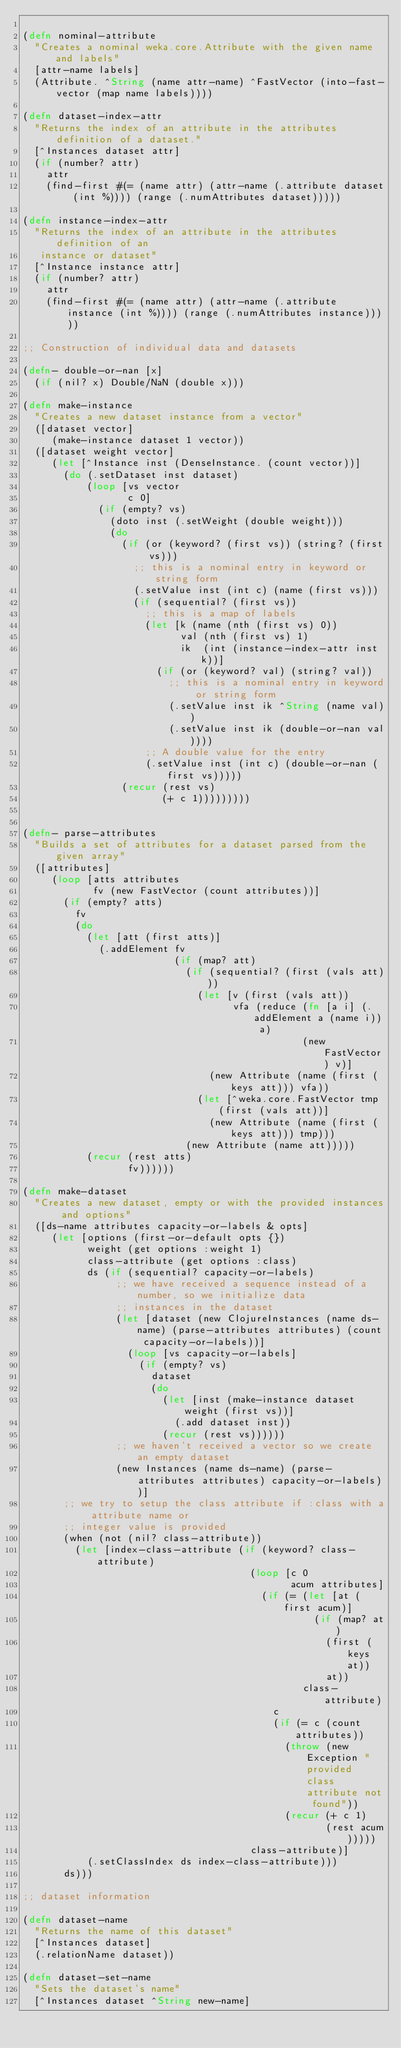<code> <loc_0><loc_0><loc_500><loc_500><_Clojure_>
(defn nominal-attribute
  "Creates a nominal weka.core.Attribute with the given name and labels"
  [attr-name labels]
  (Attribute. ^String (name attr-name) ^FastVector (into-fast-vector (map name labels))))

(defn dataset-index-attr
  "Returns the index of an attribute in the attributes definition of a dataset."
  [^Instances dataset attr]
  (if (number? attr)
    attr
    (find-first #(= (name attr) (attr-name (.attribute dataset (int %)))) (range (.numAttributes dataset)))))

(defn instance-index-attr
  "Returns the index of an attribute in the attributes definition of an
   instance or dataset"
  [^Instance instance attr]
  (if (number? attr)
    attr
    (find-first #(= (name attr) (attr-name (.attribute instance (int %)))) (range (.numAttributes instance)))))

;; Construction of individual data and datasets

(defn- double-or-nan [x]
  (if (nil? x) Double/NaN (double x)))

(defn make-instance
  "Creates a new dataset instance from a vector"
  ([dataset vector]
     (make-instance dataset 1 vector))
  ([dataset weight vector]
     (let [^Instance inst (DenseInstance. (count vector))]
       (do (.setDataset inst dataset)
           (loop [vs vector
                  c 0]
             (if (empty? vs)
               (doto inst (.setWeight (double weight)))
               (do
                 (if (or (keyword? (first vs)) (string? (first vs)))
                   ;; this is a nominal entry in keyword or string form
                   (.setValue inst (int c) (name (first vs)))
                   (if (sequential? (first vs))
                     ;; this is a map of labels
                     (let [k (name (nth (first vs) 0))
                           val (nth (first vs) 1)
                           ik  (int (instance-index-attr inst k))]
                       (if (or (keyword? val) (string? val))
                         ;; this is a nominal entry in keyword or string form
                         (.setValue inst ik ^String (name val))
                         (.setValue inst ik (double-or-nan val))))
                     ;; A double value for the entry
                     (.setValue inst (int c) (double-or-nan (first vs)))))
                 (recur (rest vs)
                        (+ c 1)))))))))


(defn- parse-attributes
  "Builds a set of attributes for a dataset parsed from the given array"
  ([attributes]
     (loop [atts attributes
            fv (new FastVector (count attributes))]
       (if (empty? atts)
         fv
         (do
           (let [att (first atts)]
             (.addElement fv
                          (if (map? att)
                            (if (sequential? (first (vals att)))
                              (let [v (first (vals att))
                                    vfa (reduce (fn [a i] (.addElement a (name i)) a)
                                                (new FastVector) v)]
                                (new Attribute (name (first (keys att))) vfa))
                              (let [^weka.core.FastVector tmp (first (vals att))]
                                (new Attribute (name (first (keys att))) tmp)))
                            (new Attribute (name att)))))
           (recur (rest atts)
                  fv))))))

(defn make-dataset
  "Creates a new dataset, empty or with the provided instances and options"
  ([ds-name attributes capacity-or-labels & opts]
     (let [options (first-or-default opts {})
           weight (get options :weight 1)
           class-attribute (get options :class)
           ds (if (sequential? capacity-or-labels)
                ;; we have received a sequence instead of a number, so we initialize data
                ;; instances in the dataset
                (let [dataset (new ClojureInstances (name ds-name) (parse-attributes attributes) (count capacity-or-labels))]
                  (loop [vs capacity-or-labels]
                    (if (empty? vs)
                      dataset
                      (do
                        (let [inst (make-instance dataset weight (first vs))]
                          (.add dataset inst))
                        (recur (rest vs))))))
                ;; we haven't received a vector so we create an empty dataset
                (new Instances (name ds-name) (parse-attributes attributes) capacity-or-labels))]
       ;; we try to setup the class attribute if :class with a attribute name or
       ;; integer value is provided
       (when (not (nil? class-attribute))
         (let [index-class-attribute (if (keyword? class-attribute)
                                       (loop [c 0
                                              acum attributes]
                                         (if (= (let [at (first acum)]
                                                  (if (map? at)
                                                    (first (keys at))
                                                    at))
                                                class-attribute)
                                           c
                                           (if (= c (count attributes))
                                             (throw (new Exception "provided class attribute not found"))
                                             (recur (+ c 1)
                                                    (rest acum)))))
                                       class-attribute)]
           (.setClassIndex ds index-class-attribute)))
       ds)))

;; dataset information

(defn dataset-name
  "Returns the name of this dataset"
  [^Instances dataset]
  (.relationName dataset))

(defn dataset-set-name
  "Sets the dataset's name"
  [^Instances dataset ^String new-name]</code> 